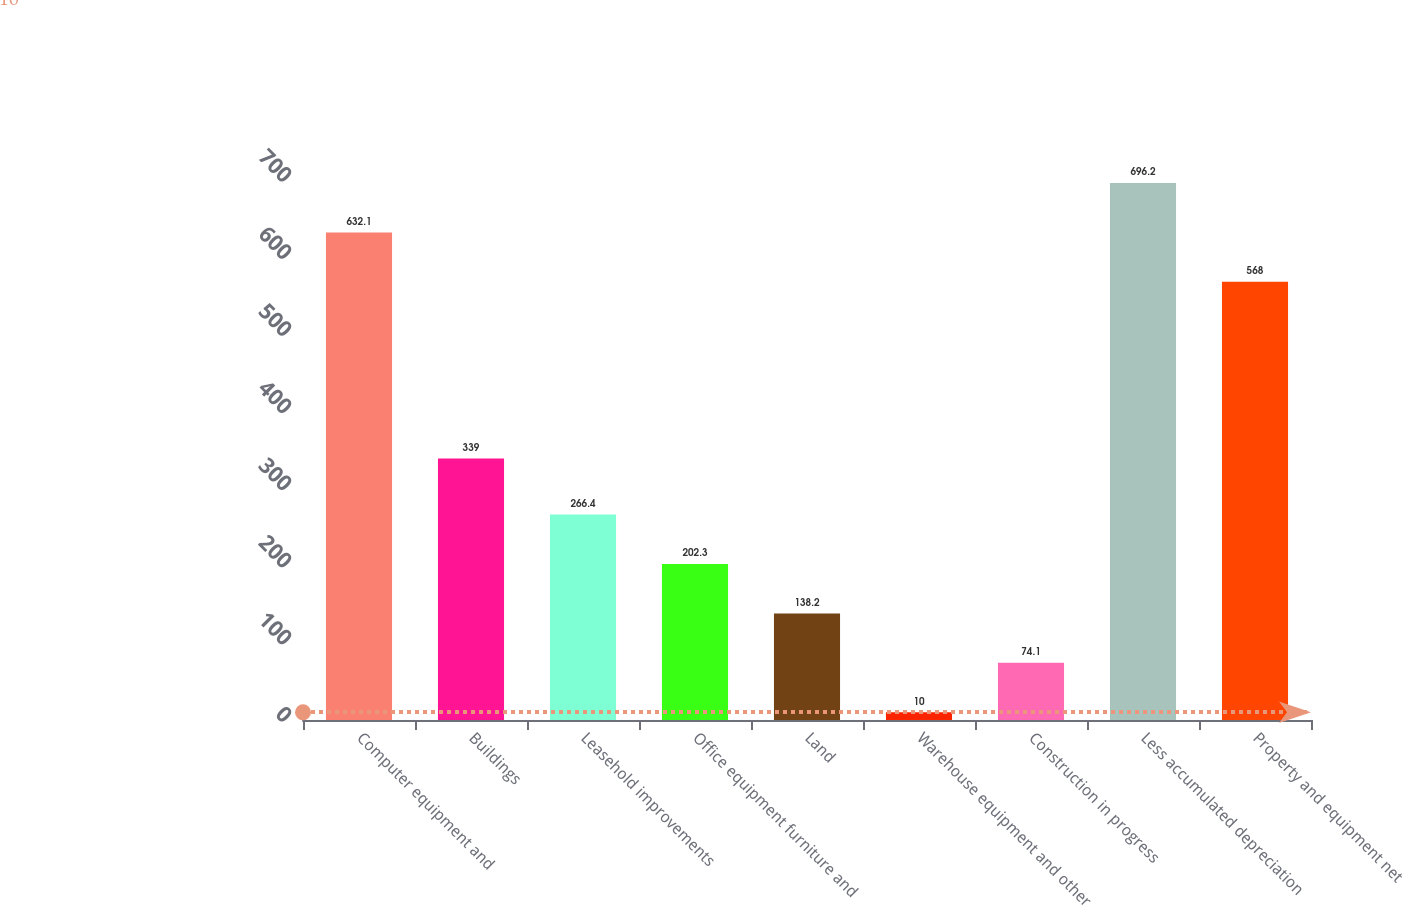Convert chart to OTSL. <chart><loc_0><loc_0><loc_500><loc_500><bar_chart><fcel>Computer equipment and<fcel>Buildings<fcel>Leasehold improvements<fcel>Office equipment furniture and<fcel>Land<fcel>Warehouse equipment and other<fcel>Construction in progress<fcel>Less accumulated depreciation<fcel>Property and equipment net<nl><fcel>632.1<fcel>339<fcel>266.4<fcel>202.3<fcel>138.2<fcel>10<fcel>74.1<fcel>696.2<fcel>568<nl></chart> 